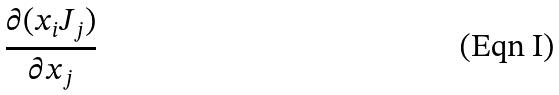<formula> <loc_0><loc_0><loc_500><loc_500>\frac { \partial ( x _ { i } J _ { j } ) } { \partial x _ { j } }</formula> 